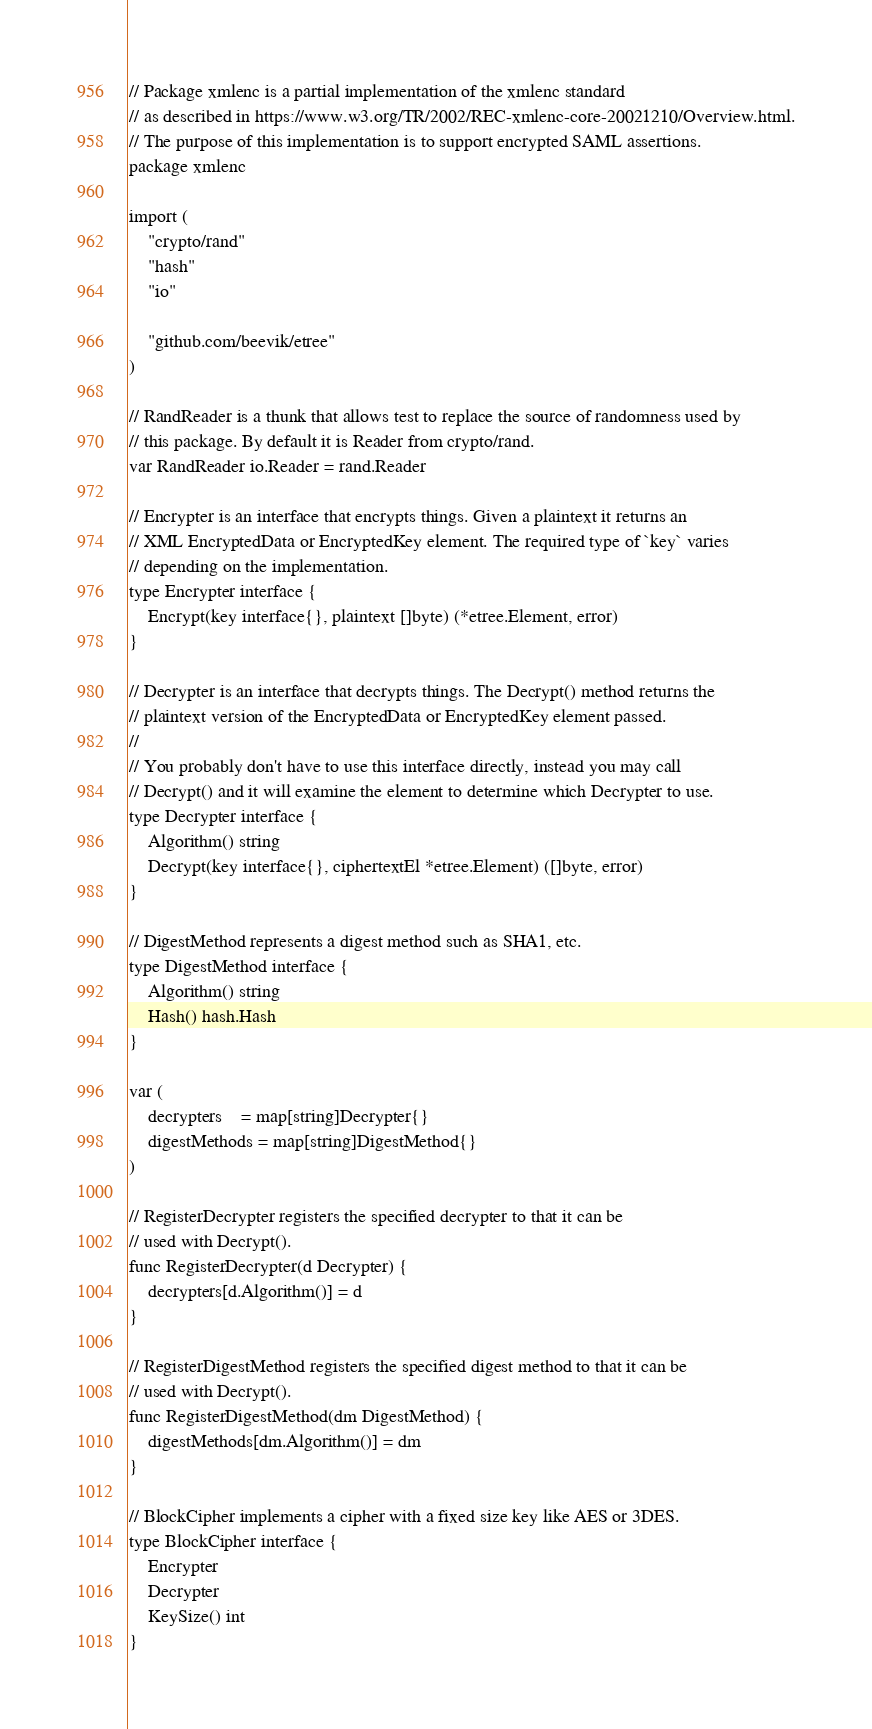<code> <loc_0><loc_0><loc_500><loc_500><_Go_>// Package xmlenc is a partial implementation of the xmlenc standard
// as described in https://www.w3.org/TR/2002/REC-xmlenc-core-20021210/Overview.html.
// The purpose of this implementation is to support encrypted SAML assertions.
package xmlenc

import (
	"crypto/rand"
	"hash"
	"io"

	"github.com/beevik/etree"
)

// RandReader is a thunk that allows test to replace the source of randomness used by
// this package. By default it is Reader from crypto/rand.
var RandReader io.Reader = rand.Reader

// Encrypter is an interface that encrypts things. Given a plaintext it returns an
// XML EncryptedData or EncryptedKey element. The required type of `key` varies
// depending on the implementation.
type Encrypter interface {
	Encrypt(key interface{}, plaintext []byte) (*etree.Element, error)
}

// Decrypter is an interface that decrypts things. The Decrypt() method returns the
// plaintext version of the EncryptedData or EncryptedKey element passed.
//
// You probably don't have to use this interface directly, instead you may call
// Decrypt() and it will examine the element to determine which Decrypter to use.
type Decrypter interface {
	Algorithm() string
	Decrypt(key interface{}, ciphertextEl *etree.Element) ([]byte, error)
}

// DigestMethod represents a digest method such as SHA1, etc.
type DigestMethod interface {
	Algorithm() string
	Hash() hash.Hash
}

var (
	decrypters    = map[string]Decrypter{}
	digestMethods = map[string]DigestMethod{}
)

// RegisterDecrypter registers the specified decrypter to that it can be
// used with Decrypt().
func RegisterDecrypter(d Decrypter) {
	decrypters[d.Algorithm()] = d
}

// RegisterDigestMethod registers the specified digest method to that it can be
// used with Decrypt().
func RegisterDigestMethod(dm DigestMethod) {
	digestMethods[dm.Algorithm()] = dm
}

// BlockCipher implements a cipher with a fixed size key like AES or 3DES.
type BlockCipher interface {
	Encrypter
	Decrypter
	KeySize() int
}
</code> 